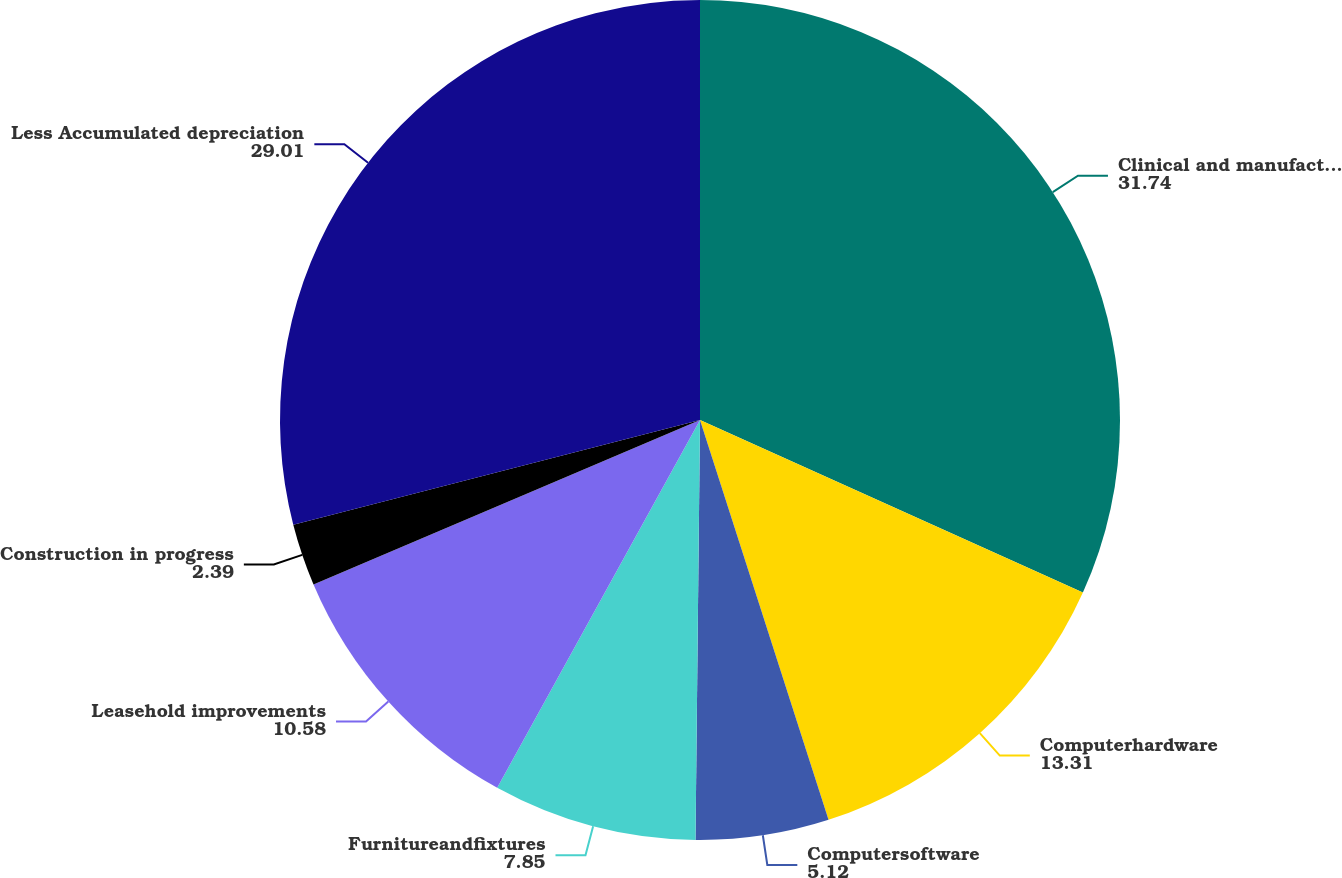Convert chart to OTSL. <chart><loc_0><loc_0><loc_500><loc_500><pie_chart><fcel>Clinical and manufacturing<fcel>Computerhardware<fcel>Computersoftware<fcel>Furnitureandfixtures<fcel>Leasehold improvements<fcel>Construction in progress<fcel>Less Accumulated depreciation<nl><fcel>31.74%<fcel>13.31%<fcel>5.12%<fcel>7.85%<fcel>10.58%<fcel>2.39%<fcel>29.01%<nl></chart> 